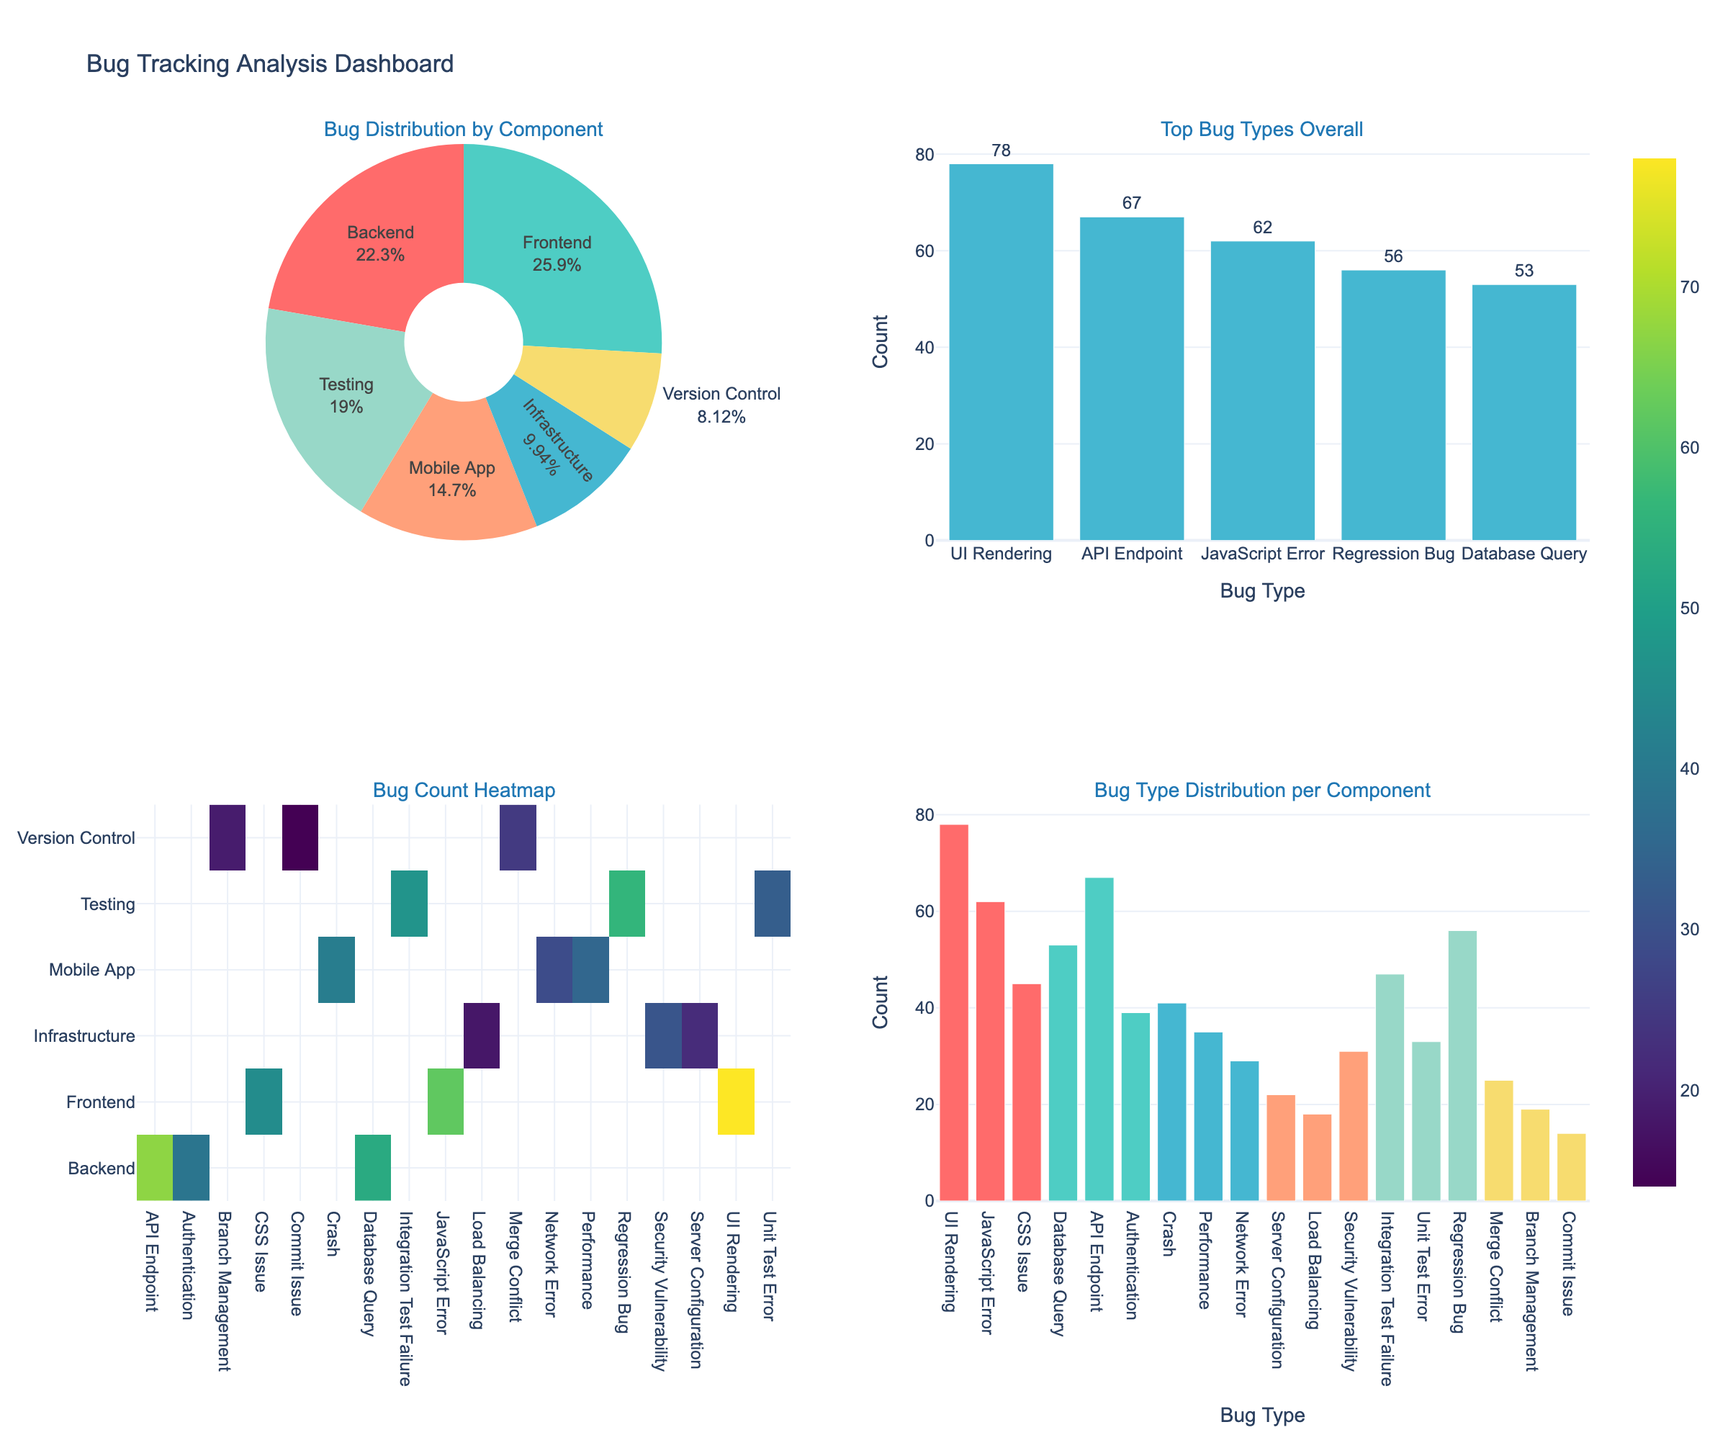What is the title of the entire figure? The title is usually placed at the top of the figure, providing an overview of what the figure represents. Here, it indicates the main subject of the visual data presented.
Answer: Bug Tracking Analysis Dashboard Which component has the highest total count of bugs in the pie chart? By observing the pie chart, you can identify the component with the largest slice, which represents the highest total count.
Answer: Frontend What percentage of the overall bugs are found in the Mobile App component? In the pie chart, each slice is labeled with both the component name and its percentage of the total count. Look for the Mobile App slice and read its label.
Answer: About 15% What are the top five bug types overall, and which one has the highest count? The bar chart in the top right subplot shows the top five bug types by count. Identify the tallest bar to determine the highest count.
Answer: UI Rendering, JavaScript Error, Regression Bug, API Endpoint, Database Query; UI Rendering Which component has the highest count for each individual bug type according to the heatmap? In the heatmap subplot, rows represent components and columns represent bug types. Identify the highest value in each column to see which component has the highest count for that bug type.
Answer: Varied per bug type, needs individual checking What is the second most common bug type reported for the Backend component? The stacked bar chart in the bottom right will show different colors for different components. Find the Backend part and identify the second tallest bar that represents the bug type.
Answer: API Endpoint What is the least common bug type in the Mobile App component? Check the stacked bar chart and look at the bars representing Mobile App. Identify the shortest bar to find the least common bug type.
Answer: Network Error 